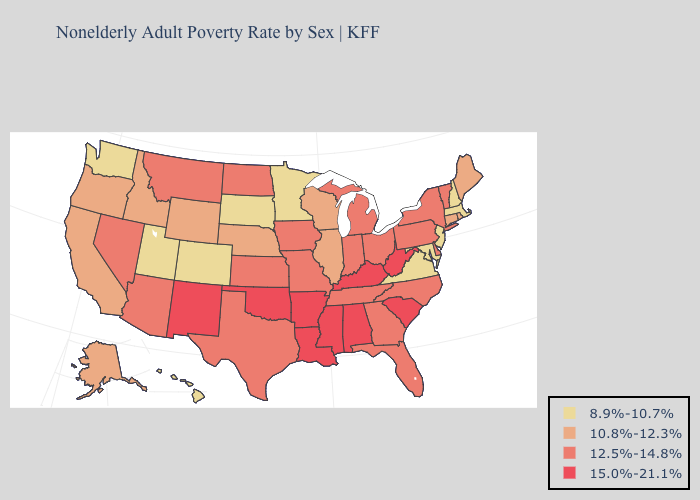Among the states that border Delaware , which have the highest value?
Be succinct. Pennsylvania. Name the states that have a value in the range 10.8%-12.3%?
Short answer required. Alaska, California, Connecticut, Idaho, Illinois, Maine, Nebraska, Oregon, Rhode Island, Wisconsin, Wyoming. Name the states that have a value in the range 12.5%-14.8%?
Keep it brief. Arizona, Delaware, Florida, Georgia, Indiana, Iowa, Kansas, Michigan, Missouri, Montana, Nevada, New York, North Carolina, North Dakota, Ohio, Pennsylvania, Tennessee, Texas, Vermont. What is the value of Nebraska?
Be succinct. 10.8%-12.3%. Name the states that have a value in the range 15.0%-21.1%?
Concise answer only. Alabama, Arkansas, Kentucky, Louisiana, Mississippi, New Mexico, Oklahoma, South Carolina, West Virginia. Does Illinois have the highest value in the MidWest?
Short answer required. No. Does Maryland have the lowest value in the South?
Write a very short answer. Yes. Name the states that have a value in the range 12.5%-14.8%?
Be succinct. Arizona, Delaware, Florida, Georgia, Indiana, Iowa, Kansas, Michigan, Missouri, Montana, Nevada, New York, North Carolina, North Dakota, Ohio, Pennsylvania, Tennessee, Texas, Vermont. Among the states that border West Virginia , does Virginia have the lowest value?
Write a very short answer. Yes. Name the states that have a value in the range 12.5%-14.8%?
Be succinct. Arizona, Delaware, Florida, Georgia, Indiana, Iowa, Kansas, Michigan, Missouri, Montana, Nevada, New York, North Carolina, North Dakota, Ohio, Pennsylvania, Tennessee, Texas, Vermont. Name the states that have a value in the range 15.0%-21.1%?
Short answer required. Alabama, Arkansas, Kentucky, Louisiana, Mississippi, New Mexico, Oklahoma, South Carolina, West Virginia. What is the lowest value in the USA?
Be succinct. 8.9%-10.7%. Among the states that border West Virginia , does Maryland have the lowest value?
Keep it brief. Yes. What is the highest value in the South ?
Give a very brief answer. 15.0%-21.1%. Name the states that have a value in the range 10.8%-12.3%?
Concise answer only. Alaska, California, Connecticut, Idaho, Illinois, Maine, Nebraska, Oregon, Rhode Island, Wisconsin, Wyoming. 